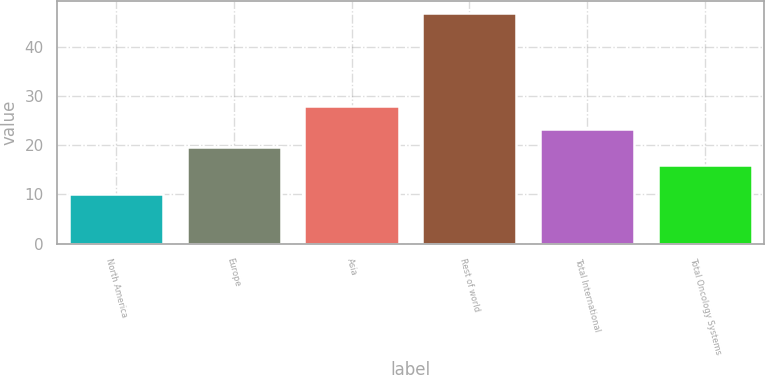<chart> <loc_0><loc_0><loc_500><loc_500><bar_chart><fcel>North America<fcel>Europe<fcel>Asia<fcel>Rest of world<fcel>Total International<fcel>Total Oncology Systems<nl><fcel>10<fcel>19.7<fcel>28<fcel>47<fcel>23.4<fcel>16<nl></chart> 